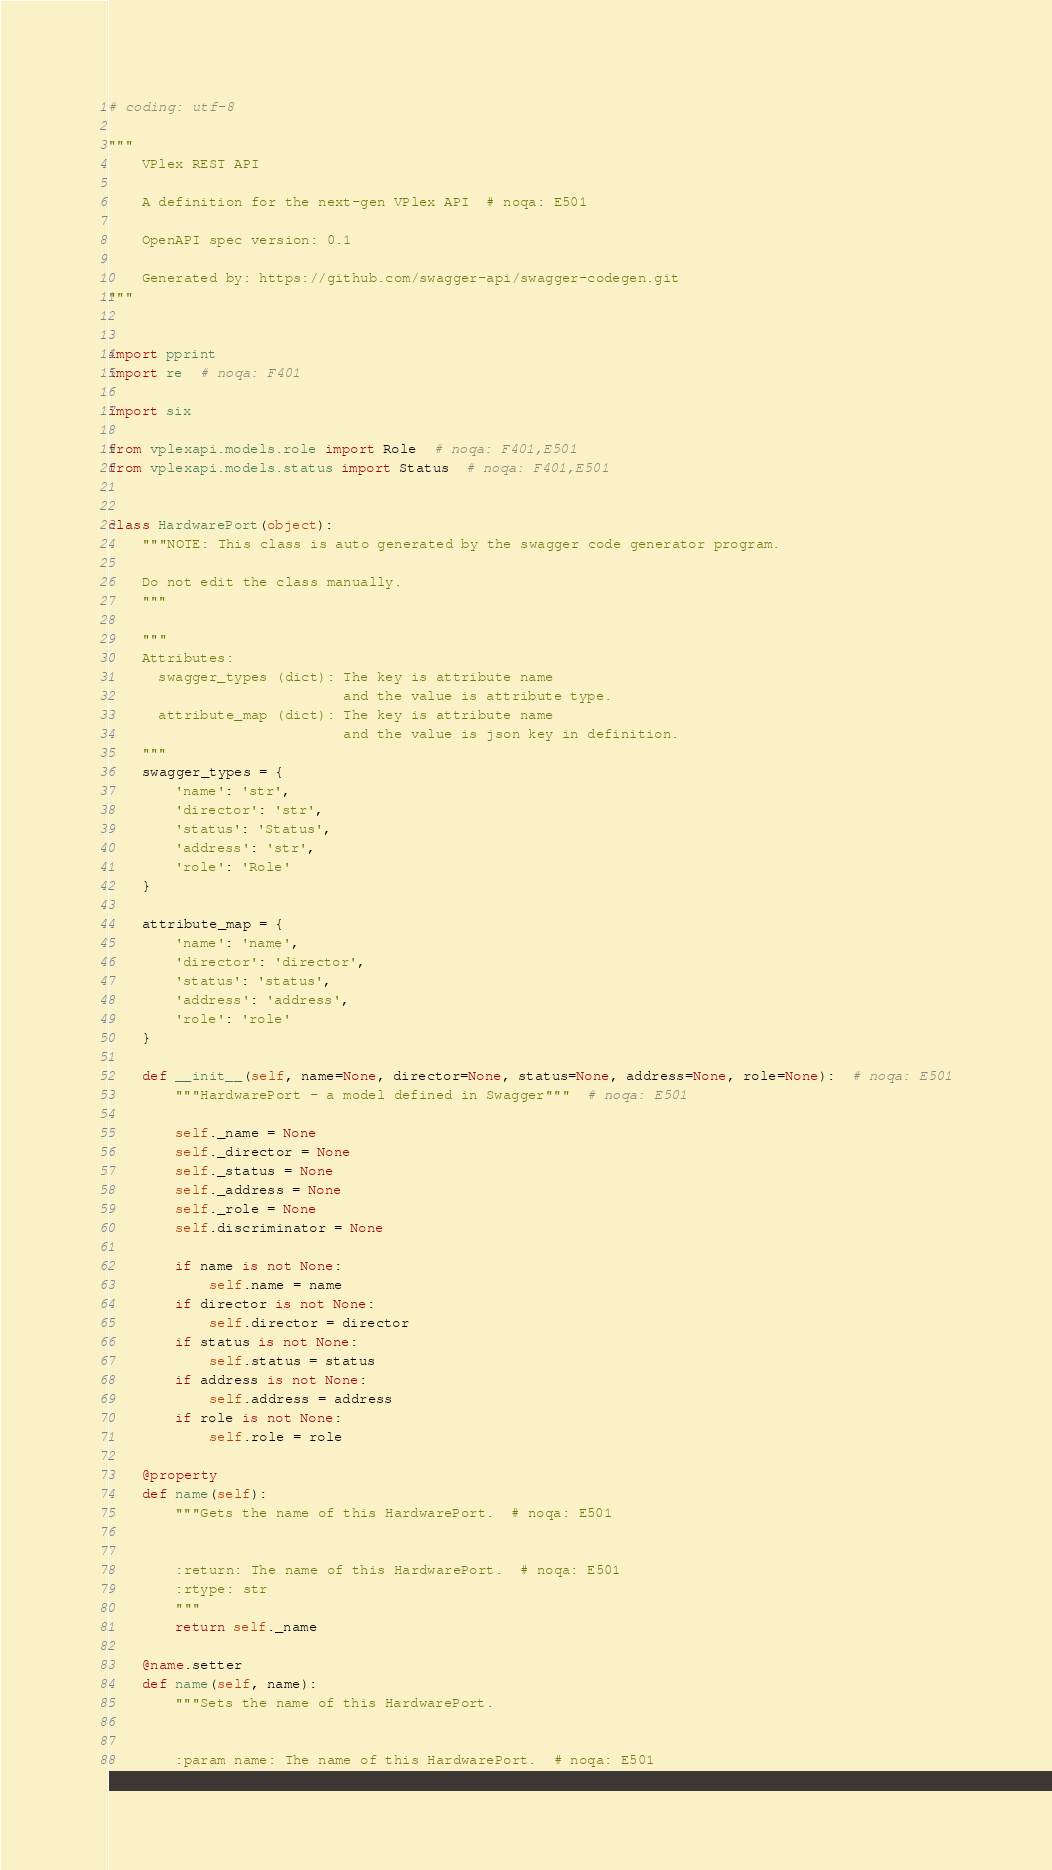Convert code to text. <code><loc_0><loc_0><loc_500><loc_500><_Python_># coding: utf-8

"""
    VPlex REST API

    A definition for the next-gen VPlex API  # noqa: E501

    OpenAPI spec version: 0.1
    
    Generated by: https://github.com/swagger-api/swagger-codegen.git
"""


import pprint
import re  # noqa: F401

import six

from vplexapi.models.role import Role  # noqa: F401,E501
from vplexapi.models.status import Status  # noqa: F401,E501


class HardwarePort(object):
    """NOTE: This class is auto generated by the swagger code generator program.

    Do not edit the class manually.
    """

    """
    Attributes:
      swagger_types (dict): The key is attribute name
                            and the value is attribute type.
      attribute_map (dict): The key is attribute name
                            and the value is json key in definition.
    """
    swagger_types = {
        'name': 'str',
        'director': 'str',
        'status': 'Status',
        'address': 'str',
        'role': 'Role'
    }

    attribute_map = {
        'name': 'name',
        'director': 'director',
        'status': 'status',
        'address': 'address',
        'role': 'role'
    }

    def __init__(self, name=None, director=None, status=None, address=None, role=None):  # noqa: E501
        """HardwarePort - a model defined in Swagger"""  # noqa: E501

        self._name = None
        self._director = None
        self._status = None
        self._address = None
        self._role = None
        self.discriminator = None

        if name is not None:
            self.name = name
        if director is not None:
            self.director = director
        if status is not None:
            self.status = status
        if address is not None:
            self.address = address
        if role is not None:
            self.role = role

    @property
    def name(self):
        """Gets the name of this HardwarePort.  # noqa: E501


        :return: The name of this HardwarePort.  # noqa: E501
        :rtype: str
        """
        return self._name

    @name.setter
    def name(self, name):
        """Sets the name of this HardwarePort.


        :param name: The name of this HardwarePort.  # noqa: E501</code> 